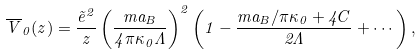Convert formula to latex. <formula><loc_0><loc_0><loc_500><loc_500>\overline { V } _ { 0 } ( z ) = \frac { \tilde { e } ^ { 2 } } { z } \left ( \frac { m a _ { B } } { 4 \pi \kappa _ { 0 } \Lambda } \right ) ^ { 2 } \left ( 1 - \frac { m a _ { B } / \pi \kappa _ { 0 } + 4 C } { 2 \Lambda } + \cdots \right ) ,</formula> 